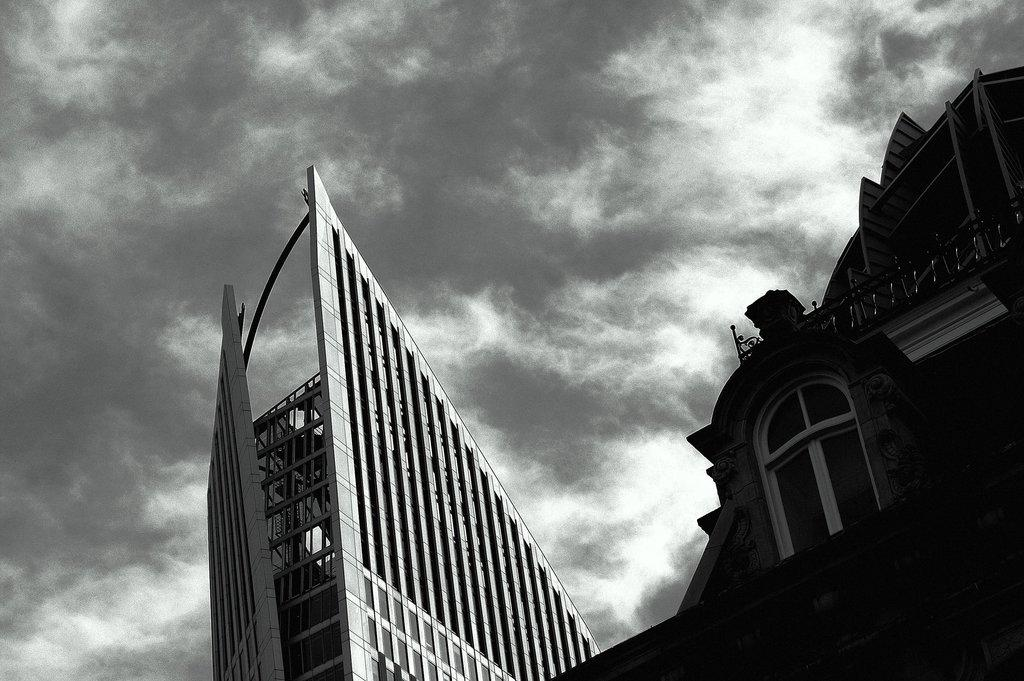What type of structures can be seen in the image? There are buildings in the image. What is the condition of the sky in the image? The sky is cloudy in the image. How many fish are swimming in the buildings in the image? There are no fish present in the image, as it features buildings and a cloudy sky. 